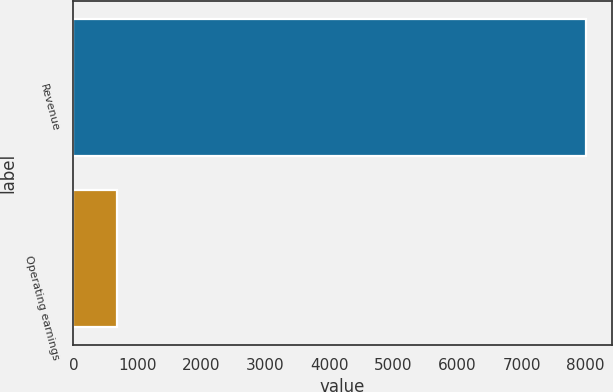<chart> <loc_0><loc_0><loc_500><loc_500><bar_chart><fcel>Revenue<fcel>Operating earnings<nl><fcel>8004<fcel>685<nl></chart> 